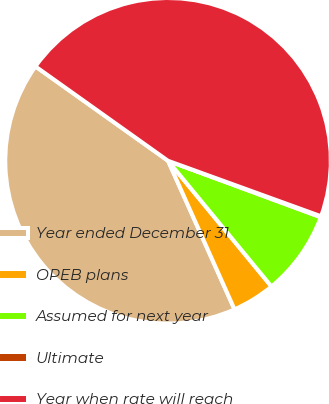<chart> <loc_0><loc_0><loc_500><loc_500><pie_chart><fcel>Year ended December 31<fcel>OPEB plans<fcel>Assumed for next year<fcel>Ultimate<fcel>Year when rate will reach<nl><fcel>41.54%<fcel>4.26%<fcel>8.41%<fcel>0.1%<fcel>45.69%<nl></chart> 